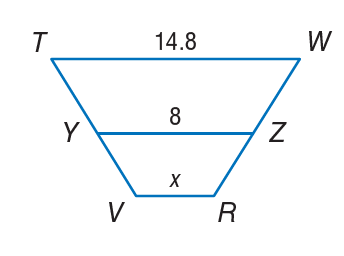Question: In the figure at the right, Y Z is the midsegment of trapezoid T W R V. Determine the value of x.
Choices:
A. 1.2
B. 8
C. 14.8
D. 16
Answer with the letter. Answer: A 